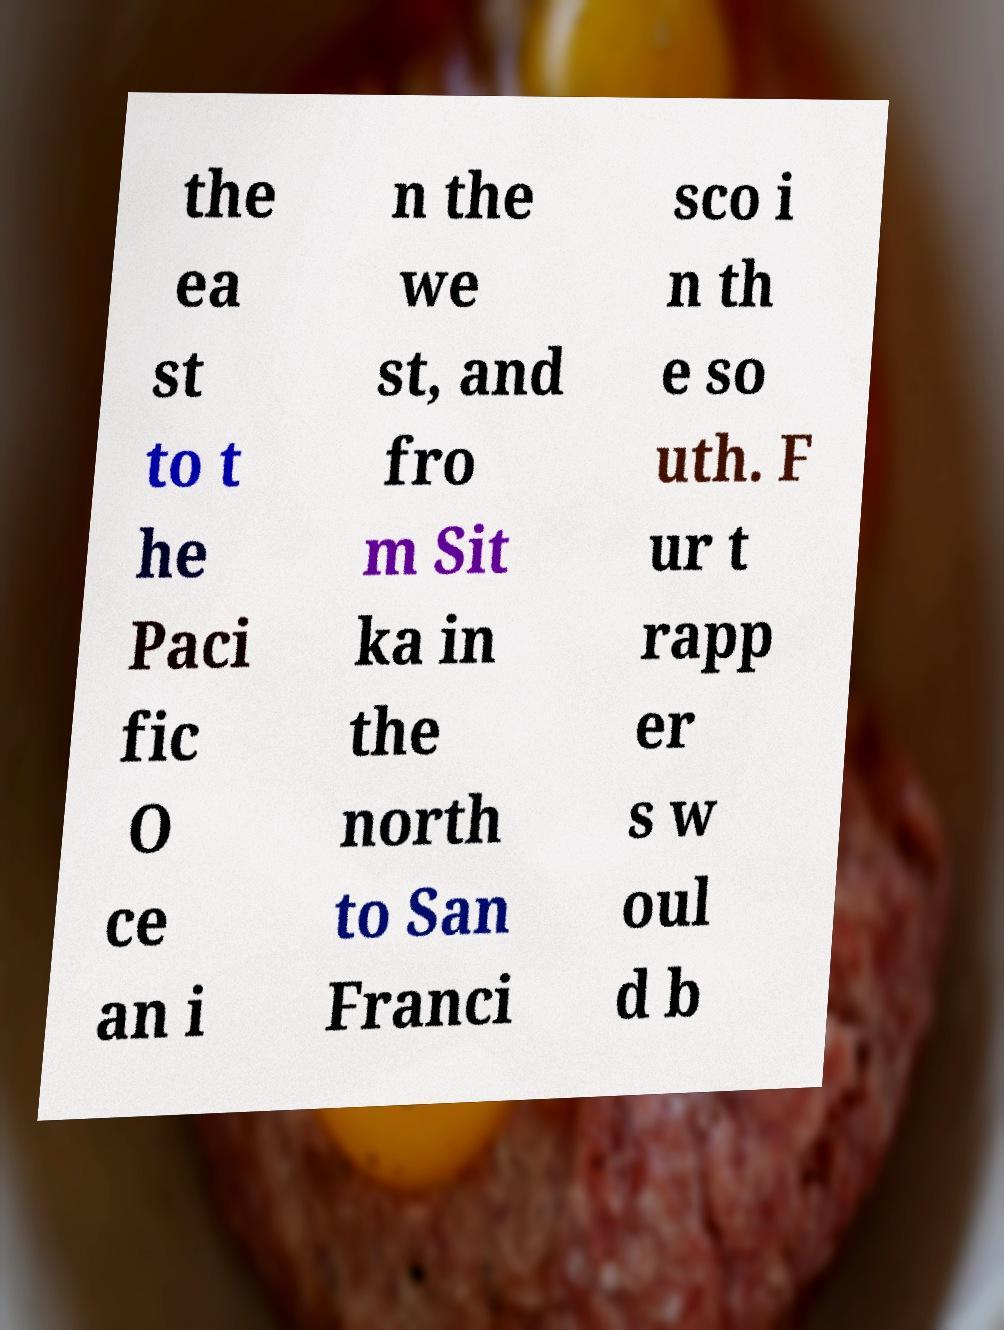What messages or text are displayed in this image? I need them in a readable, typed format. the ea st to t he Paci fic O ce an i n the we st, and fro m Sit ka in the north to San Franci sco i n th e so uth. F ur t rapp er s w oul d b 